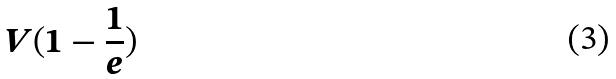<formula> <loc_0><loc_0><loc_500><loc_500>V ( 1 - \frac { 1 } { e } )</formula> 